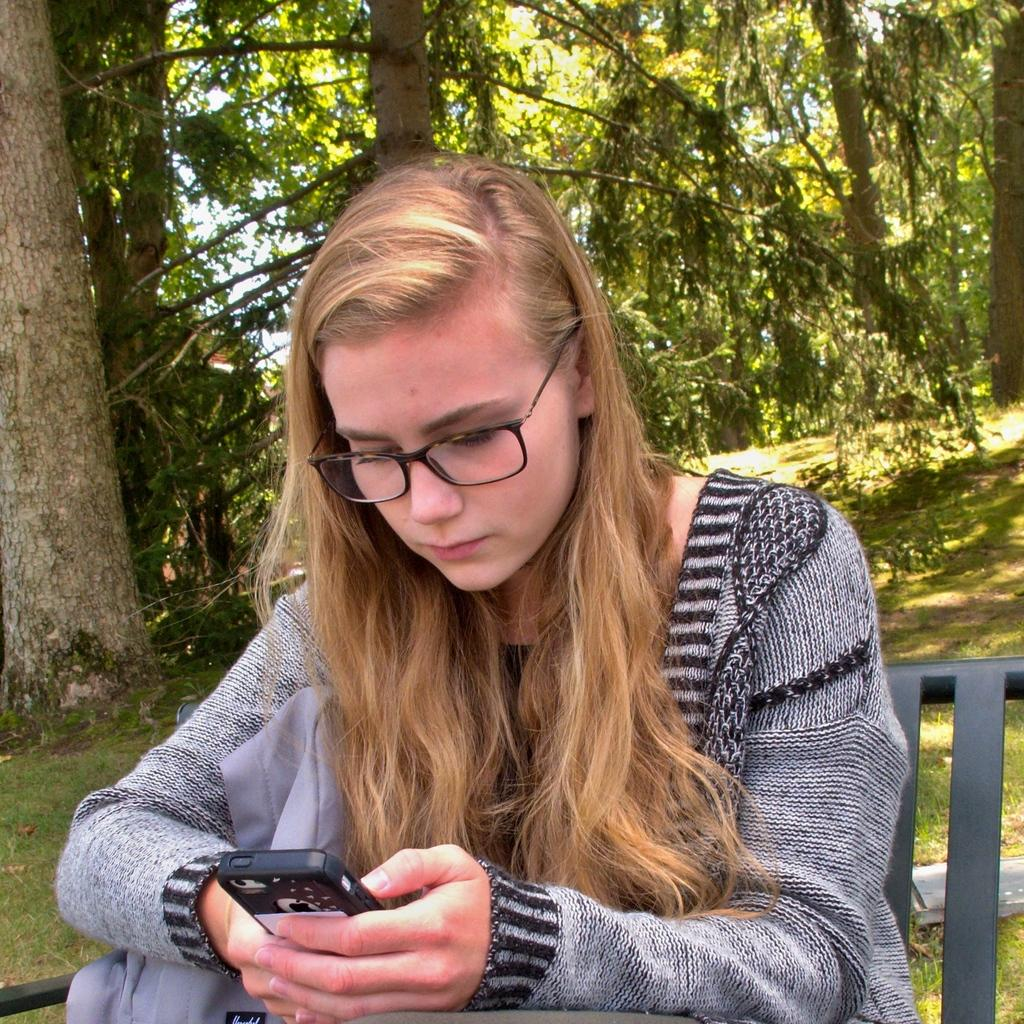Who is present in the image? There is a woman in the image. What is the woman doing in the image? The woman is sitting on a chair in the image. What is the woman holding in her hands? The woman is holding a mobile in her hands. What can be seen in the background of the image? There are trees visible in the background of the image. What type of ground surface is visible in the image? There is grass in the image. What type of sound can be heard coming from the sack in the image? There is no sack present in the image, so it is not possible to determine what, if any, sound might be heard. 